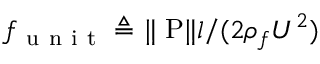Convert formula to latex. <formula><loc_0><loc_0><loc_500><loc_500>f _ { u n i t } \triangle q \| \nabla { P } \| l / ( 2 \rho _ { f } U ^ { 2 } )</formula> 